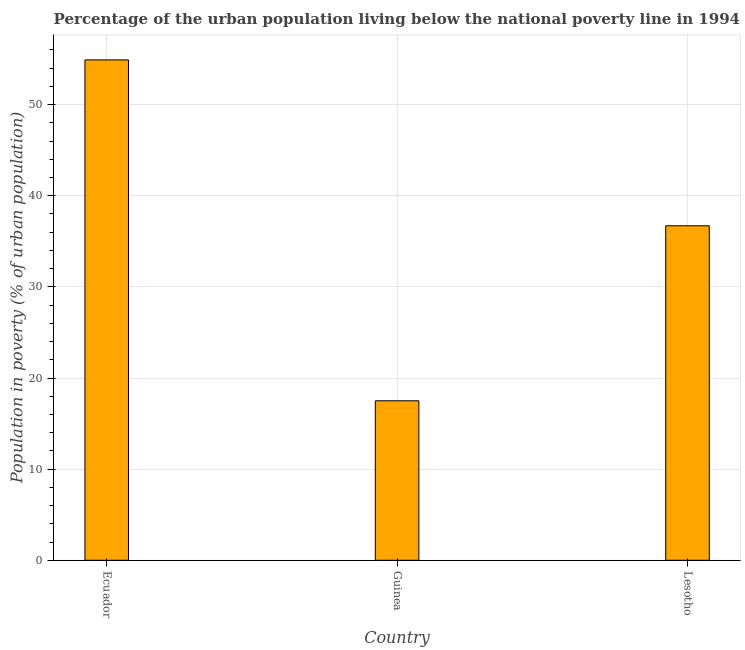Does the graph contain grids?
Provide a short and direct response. Yes. What is the title of the graph?
Make the answer very short. Percentage of the urban population living below the national poverty line in 1994. What is the label or title of the Y-axis?
Give a very brief answer. Population in poverty (% of urban population). What is the percentage of urban population living below poverty line in Lesotho?
Make the answer very short. 36.7. Across all countries, what is the maximum percentage of urban population living below poverty line?
Provide a short and direct response. 54.9. In which country was the percentage of urban population living below poverty line maximum?
Your answer should be very brief. Ecuador. In which country was the percentage of urban population living below poverty line minimum?
Provide a short and direct response. Guinea. What is the sum of the percentage of urban population living below poverty line?
Keep it short and to the point. 109.1. What is the difference between the percentage of urban population living below poverty line in Ecuador and Lesotho?
Ensure brevity in your answer.  18.2. What is the average percentage of urban population living below poverty line per country?
Offer a terse response. 36.37. What is the median percentage of urban population living below poverty line?
Give a very brief answer. 36.7. In how many countries, is the percentage of urban population living below poverty line greater than 4 %?
Give a very brief answer. 3. What is the ratio of the percentage of urban population living below poverty line in Ecuador to that in Guinea?
Your response must be concise. 3.14. Is the percentage of urban population living below poverty line in Ecuador less than that in Guinea?
Make the answer very short. No. What is the difference between the highest and the second highest percentage of urban population living below poverty line?
Your response must be concise. 18.2. What is the difference between the highest and the lowest percentage of urban population living below poverty line?
Your response must be concise. 37.4. Are the values on the major ticks of Y-axis written in scientific E-notation?
Your answer should be very brief. No. What is the Population in poverty (% of urban population) in Ecuador?
Offer a terse response. 54.9. What is the Population in poverty (% of urban population) of Lesotho?
Make the answer very short. 36.7. What is the difference between the Population in poverty (% of urban population) in Ecuador and Guinea?
Provide a short and direct response. 37.4. What is the difference between the Population in poverty (% of urban population) in Guinea and Lesotho?
Provide a succinct answer. -19.2. What is the ratio of the Population in poverty (% of urban population) in Ecuador to that in Guinea?
Your answer should be very brief. 3.14. What is the ratio of the Population in poverty (% of urban population) in Ecuador to that in Lesotho?
Ensure brevity in your answer.  1.5. What is the ratio of the Population in poverty (% of urban population) in Guinea to that in Lesotho?
Your answer should be compact. 0.48. 